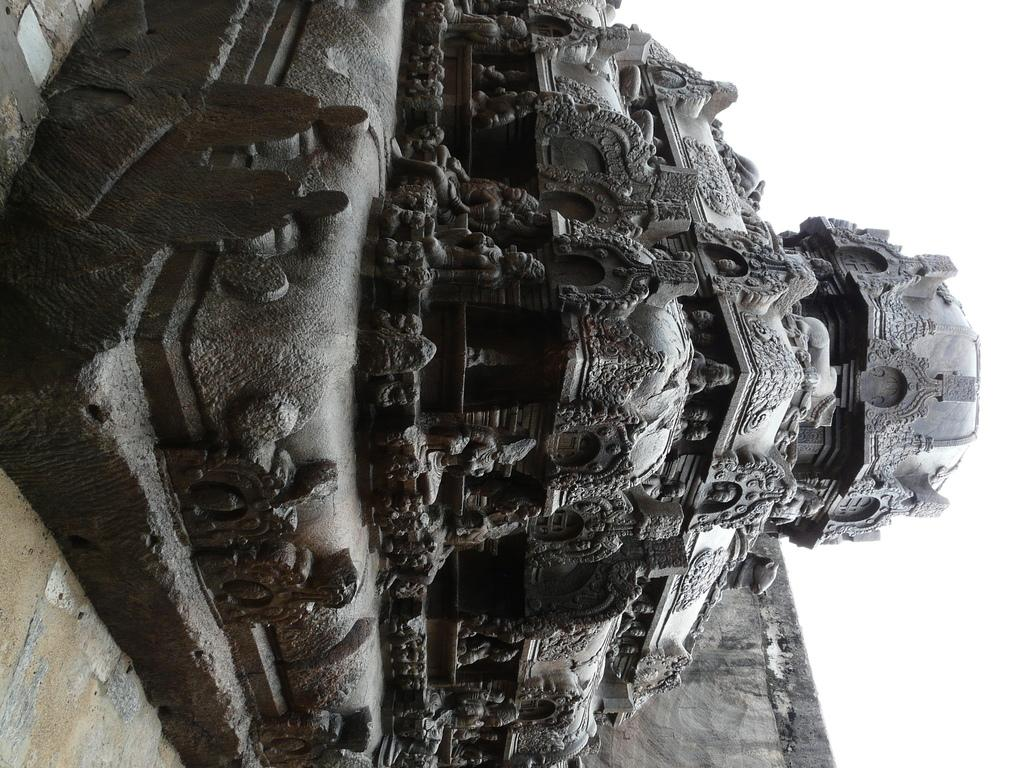What is located on the ground in the image? There is a sculpture on the ground in the image. What can be seen in the background of the image? There is a wall in the background of the image. What type of trade is being conducted in the image? There is no trade being conducted in the image; it features a sculpture on the ground and a wall in the background. What kind of cabbage is growing near the sculpture in the image? There is no cabbage present in the image; it only features a sculpture on the ground and a wall in the background. 